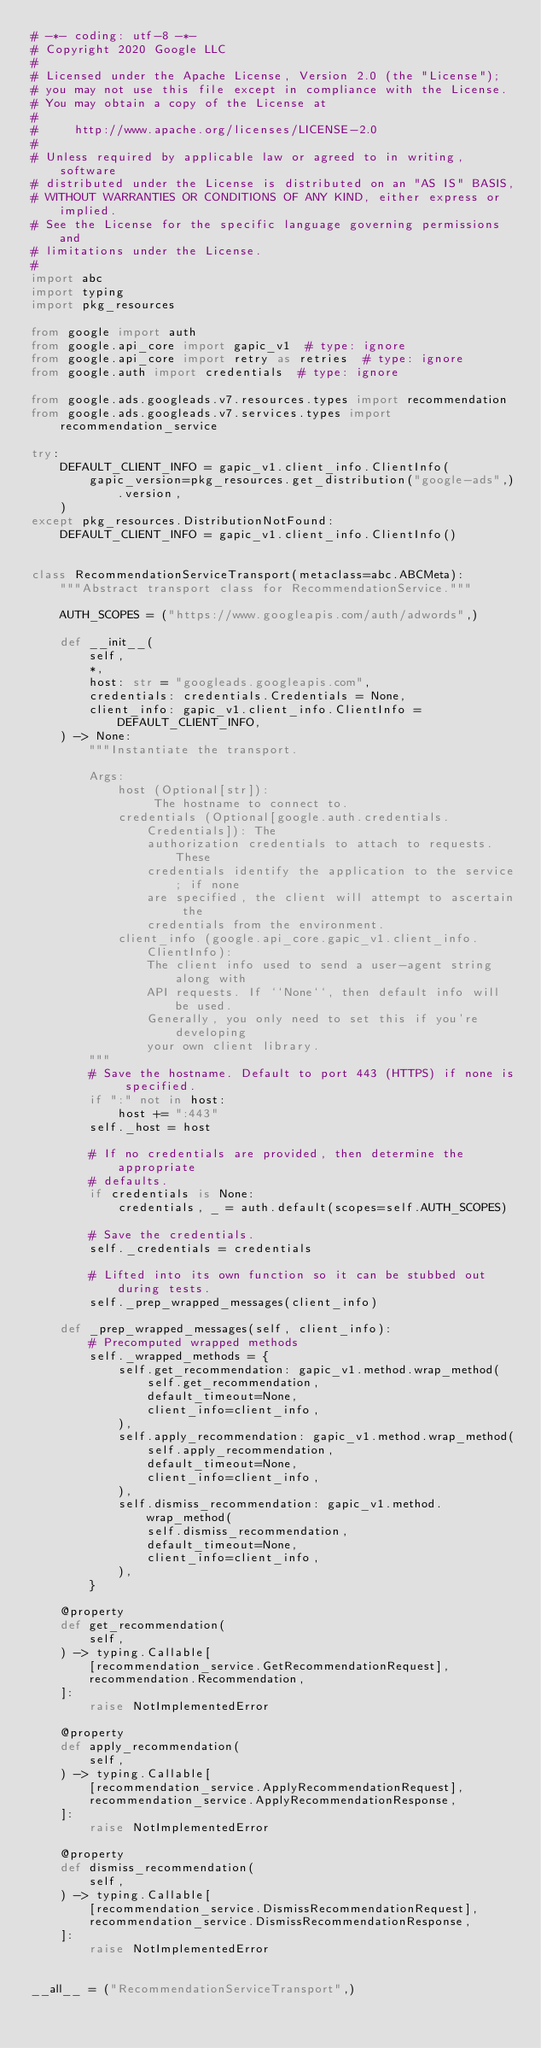Convert code to text. <code><loc_0><loc_0><loc_500><loc_500><_Python_># -*- coding: utf-8 -*-
# Copyright 2020 Google LLC
#
# Licensed under the Apache License, Version 2.0 (the "License");
# you may not use this file except in compliance with the License.
# You may obtain a copy of the License at
#
#     http://www.apache.org/licenses/LICENSE-2.0
#
# Unless required by applicable law or agreed to in writing, software
# distributed under the License is distributed on an "AS IS" BASIS,
# WITHOUT WARRANTIES OR CONDITIONS OF ANY KIND, either express or implied.
# See the License for the specific language governing permissions and
# limitations under the License.
#
import abc
import typing
import pkg_resources

from google import auth
from google.api_core import gapic_v1  # type: ignore
from google.api_core import retry as retries  # type: ignore
from google.auth import credentials  # type: ignore

from google.ads.googleads.v7.resources.types import recommendation
from google.ads.googleads.v7.services.types import recommendation_service

try:
    DEFAULT_CLIENT_INFO = gapic_v1.client_info.ClientInfo(
        gapic_version=pkg_resources.get_distribution("google-ads",).version,
    )
except pkg_resources.DistributionNotFound:
    DEFAULT_CLIENT_INFO = gapic_v1.client_info.ClientInfo()


class RecommendationServiceTransport(metaclass=abc.ABCMeta):
    """Abstract transport class for RecommendationService."""

    AUTH_SCOPES = ("https://www.googleapis.com/auth/adwords",)

    def __init__(
        self,
        *,
        host: str = "googleads.googleapis.com",
        credentials: credentials.Credentials = None,
        client_info: gapic_v1.client_info.ClientInfo = DEFAULT_CLIENT_INFO,
    ) -> None:
        """Instantiate the transport.

        Args:
            host (Optional[str]):
                 The hostname to connect to.
            credentials (Optional[google.auth.credentials.Credentials]): The
                authorization credentials to attach to requests. These
                credentials identify the application to the service; if none
                are specified, the client will attempt to ascertain the
                credentials from the environment.
            client_info (google.api_core.gapic_v1.client_info.ClientInfo):
                The client info used to send a user-agent string along with
                API requests. If ``None``, then default info will be used.
                Generally, you only need to set this if you're developing
                your own client library.
        """
        # Save the hostname. Default to port 443 (HTTPS) if none is specified.
        if ":" not in host:
            host += ":443"
        self._host = host

        # If no credentials are provided, then determine the appropriate
        # defaults.
        if credentials is None:
            credentials, _ = auth.default(scopes=self.AUTH_SCOPES)

        # Save the credentials.
        self._credentials = credentials

        # Lifted into its own function so it can be stubbed out during tests.
        self._prep_wrapped_messages(client_info)

    def _prep_wrapped_messages(self, client_info):
        # Precomputed wrapped methods
        self._wrapped_methods = {
            self.get_recommendation: gapic_v1.method.wrap_method(
                self.get_recommendation,
                default_timeout=None,
                client_info=client_info,
            ),
            self.apply_recommendation: gapic_v1.method.wrap_method(
                self.apply_recommendation,
                default_timeout=None,
                client_info=client_info,
            ),
            self.dismiss_recommendation: gapic_v1.method.wrap_method(
                self.dismiss_recommendation,
                default_timeout=None,
                client_info=client_info,
            ),
        }

    @property
    def get_recommendation(
        self,
    ) -> typing.Callable[
        [recommendation_service.GetRecommendationRequest],
        recommendation.Recommendation,
    ]:
        raise NotImplementedError

    @property
    def apply_recommendation(
        self,
    ) -> typing.Callable[
        [recommendation_service.ApplyRecommendationRequest],
        recommendation_service.ApplyRecommendationResponse,
    ]:
        raise NotImplementedError

    @property
    def dismiss_recommendation(
        self,
    ) -> typing.Callable[
        [recommendation_service.DismissRecommendationRequest],
        recommendation_service.DismissRecommendationResponse,
    ]:
        raise NotImplementedError


__all__ = ("RecommendationServiceTransport",)
</code> 